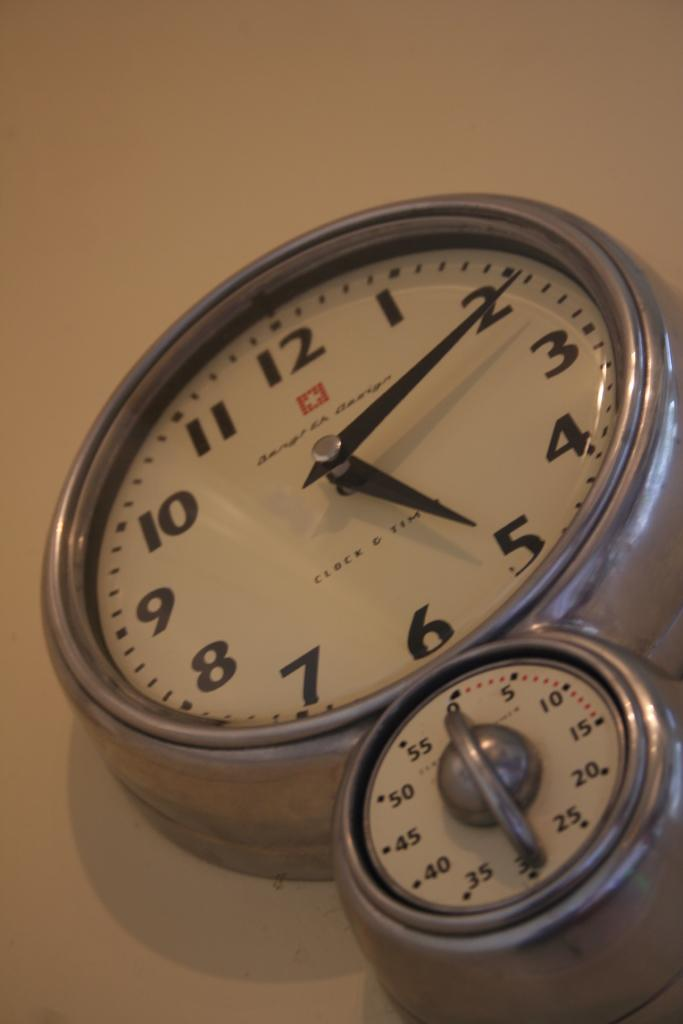Provide a one-sentence caption for the provided image. Clock which has the hands on the numbers 2 and 5 above a small timer. 